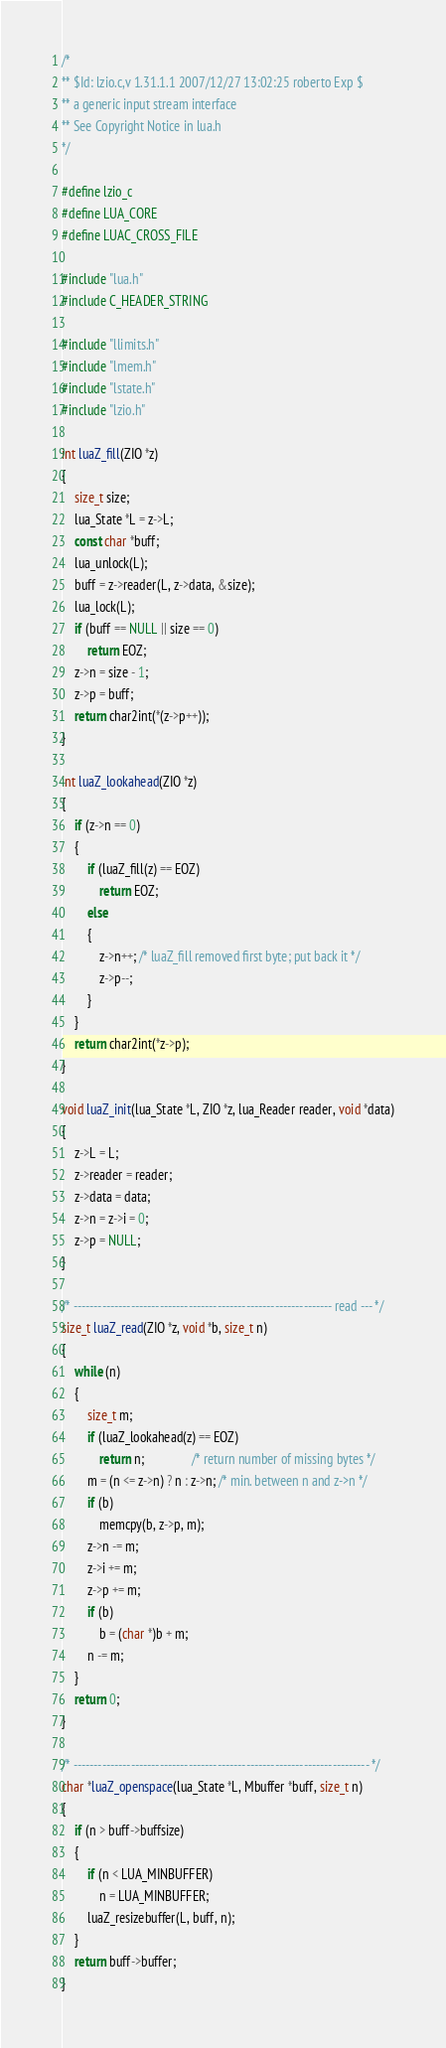Convert code to text. <code><loc_0><loc_0><loc_500><loc_500><_C_>/*
** $Id: lzio.c,v 1.31.1.1 2007/12/27 13:02:25 roberto Exp $
** a generic input stream interface
** See Copyright Notice in lua.h
*/

#define lzio_c
#define LUA_CORE
#define LUAC_CROSS_FILE

#include "lua.h"
#include C_HEADER_STRING

#include "llimits.h"
#include "lmem.h"
#include "lstate.h"
#include "lzio.h"

int luaZ_fill(ZIO *z)
{
    size_t size;
    lua_State *L = z->L;
    const char *buff;
    lua_unlock(L);
    buff = z->reader(L, z->data, &size);
    lua_lock(L);
    if (buff == NULL || size == 0)
        return EOZ;
    z->n = size - 1;
    z->p = buff;
    return char2int(*(z->p++));
}

int luaZ_lookahead(ZIO *z)
{
    if (z->n == 0)
    {
        if (luaZ_fill(z) == EOZ)
            return EOZ;
        else
        {
            z->n++; /* luaZ_fill removed first byte; put back it */
            z->p--;
        }
    }
    return char2int(*z->p);
}

void luaZ_init(lua_State *L, ZIO *z, lua_Reader reader, void *data)
{
    z->L = L;
    z->reader = reader;
    z->data = data;
    z->n = z->i = 0;
    z->p = NULL;
}

/* --------------------------------------------------------------- read --- */
size_t luaZ_read(ZIO *z, void *b, size_t n)
{
    while (n)
    {
        size_t m;
        if (luaZ_lookahead(z) == EOZ)
            return n;               /* return number of missing bytes */
        m = (n <= z->n) ? n : z->n; /* min. between n and z->n */
        if (b)
            memcpy(b, z->p, m);
        z->n -= m;
        z->i += m;
        z->p += m;
        if (b)
            b = (char *)b + m;
        n -= m;
    }
    return 0;
}

/* ------------------------------------------------------------------------ */
char *luaZ_openspace(lua_State *L, Mbuffer *buff, size_t n)
{
    if (n > buff->buffsize)
    {
        if (n < LUA_MINBUFFER)
            n = LUA_MINBUFFER;
        luaZ_resizebuffer(L, buff, n);
    }
    return buff->buffer;
}
</code> 